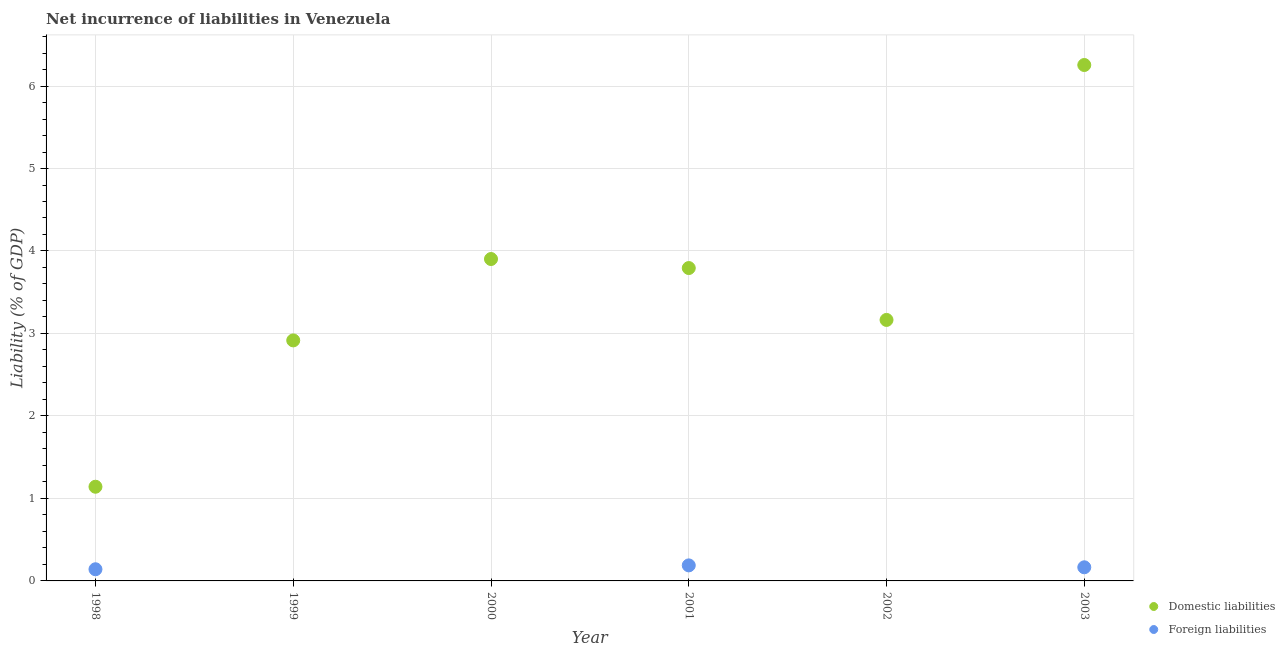Is the number of dotlines equal to the number of legend labels?
Offer a terse response. No. What is the incurrence of foreign liabilities in 1998?
Your answer should be compact. 0.14. Across all years, what is the maximum incurrence of foreign liabilities?
Provide a short and direct response. 0.19. Across all years, what is the minimum incurrence of domestic liabilities?
Provide a succinct answer. 1.14. In which year was the incurrence of domestic liabilities maximum?
Your answer should be very brief. 2003. What is the total incurrence of domestic liabilities in the graph?
Keep it short and to the point. 21.17. What is the difference between the incurrence of domestic liabilities in 2000 and that in 2003?
Your answer should be very brief. -2.35. What is the difference between the incurrence of domestic liabilities in 1998 and the incurrence of foreign liabilities in 2000?
Ensure brevity in your answer.  1.14. What is the average incurrence of foreign liabilities per year?
Give a very brief answer. 0.08. In the year 2001, what is the difference between the incurrence of foreign liabilities and incurrence of domestic liabilities?
Offer a terse response. -3.6. What is the ratio of the incurrence of domestic liabilities in 2000 to that in 2002?
Offer a very short reply. 1.23. Is the incurrence of domestic liabilities in 2001 less than that in 2002?
Ensure brevity in your answer.  No. What is the difference between the highest and the second highest incurrence of foreign liabilities?
Offer a very short reply. 0.02. What is the difference between the highest and the lowest incurrence of domestic liabilities?
Your answer should be compact. 5.11. Does the incurrence of domestic liabilities monotonically increase over the years?
Your answer should be compact. No. How many dotlines are there?
Your answer should be very brief. 2. How many years are there in the graph?
Give a very brief answer. 6. Does the graph contain any zero values?
Your response must be concise. Yes. Does the graph contain grids?
Provide a succinct answer. Yes. Where does the legend appear in the graph?
Provide a succinct answer. Bottom right. How many legend labels are there?
Your answer should be very brief. 2. How are the legend labels stacked?
Provide a short and direct response. Vertical. What is the title of the graph?
Provide a short and direct response. Net incurrence of liabilities in Venezuela. What is the label or title of the X-axis?
Provide a short and direct response. Year. What is the label or title of the Y-axis?
Offer a terse response. Liability (% of GDP). What is the Liability (% of GDP) of Domestic liabilities in 1998?
Your answer should be compact. 1.14. What is the Liability (% of GDP) in Foreign liabilities in 1998?
Ensure brevity in your answer.  0.14. What is the Liability (% of GDP) of Domestic liabilities in 1999?
Give a very brief answer. 2.92. What is the Liability (% of GDP) of Foreign liabilities in 1999?
Your response must be concise. 0. What is the Liability (% of GDP) in Domestic liabilities in 2000?
Make the answer very short. 3.9. What is the Liability (% of GDP) in Foreign liabilities in 2000?
Your answer should be compact. 0. What is the Liability (% of GDP) in Domestic liabilities in 2001?
Give a very brief answer. 3.79. What is the Liability (% of GDP) of Foreign liabilities in 2001?
Your answer should be compact. 0.19. What is the Liability (% of GDP) of Domestic liabilities in 2002?
Offer a very short reply. 3.16. What is the Liability (% of GDP) in Foreign liabilities in 2002?
Your answer should be compact. 0. What is the Liability (% of GDP) in Domestic liabilities in 2003?
Provide a succinct answer. 6.25. What is the Liability (% of GDP) in Foreign liabilities in 2003?
Your answer should be compact. 0.17. Across all years, what is the maximum Liability (% of GDP) in Domestic liabilities?
Ensure brevity in your answer.  6.25. Across all years, what is the maximum Liability (% of GDP) of Foreign liabilities?
Provide a succinct answer. 0.19. Across all years, what is the minimum Liability (% of GDP) of Domestic liabilities?
Keep it short and to the point. 1.14. Across all years, what is the minimum Liability (% of GDP) of Foreign liabilities?
Keep it short and to the point. 0. What is the total Liability (% of GDP) in Domestic liabilities in the graph?
Your response must be concise. 21.17. What is the total Liability (% of GDP) in Foreign liabilities in the graph?
Make the answer very short. 0.49. What is the difference between the Liability (% of GDP) in Domestic liabilities in 1998 and that in 1999?
Keep it short and to the point. -1.77. What is the difference between the Liability (% of GDP) in Domestic liabilities in 1998 and that in 2000?
Ensure brevity in your answer.  -2.76. What is the difference between the Liability (% of GDP) in Domestic liabilities in 1998 and that in 2001?
Your answer should be very brief. -2.65. What is the difference between the Liability (% of GDP) in Foreign liabilities in 1998 and that in 2001?
Your answer should be compact. -0.05. What is the difference between the Liability (% of GDP) of Domestic liabilities in 1998 and that in 2002?
Your answer should be compact. -2.02. What is the difference between the Liability (% of GDP) of Domestic liabilities in 1998 and that in 2003?
Your response must be concise. -5.11. What is the difference between the Liability (% of GDP) in Foreign liabilities in 1998 and that in 2003?
Give a very brief answer. -0.02. What is the difference between the Liability (% of GDP) in Domestic liabilities in 1999 and that in 2000?
Ensure brevity in your answer.  -0.99. What is the difference between the Liability (% of GDP) in Domestic liabilities in 1999 and that in 2001?
Ensure brevity in your answer.  -0.88. What is the difference between the Liability (% of GDP) in Domestic liabilities in 1999 and that in 2002?
Make the answer very short. -0.25. What is the difference between the Liability (% of GDP) of Domestic liabilities in 1999 and that in 2003?
Provide a succinct answer. -3.34. What is the difference between the Liability (% of GDP) in Domestic liabilities in 2000 and that in 2001?
Your answer should be very brief. 0.11. What is the difference between the Liability (% of GDP) of Domestic liabilities in 2000 and that in 2002?
Ensure brevity in your answer.  0.74. What is the difference between the Liability (% of GDP) in Domestic liabilities in 2000 and that in 2003?
Make the answer very short. -2.35. What is the difference between the Liability (% of GDP) in Domestic liabilities in 2001 and that in 2002?
Your answer should be compact. 0.63. What is the difference between the Liability (% of GDP) of Domestic liabilities in 2001 and that in 2003?
Your answer should be very brief. -2.46. What is the difference between the Liability (% of GDP) in Foreign liabilities in 2001 and that in 2003?
Your response must be concise. 0.02. What is the difference between the Liability (% of GDP) in Domestic liabilities in 2002 and that in 2003?
Offer a terse response. -3.09. What is the difference between the Liability (% of GDP) in Domestic liabilities in 1998 and the Liability (% of GDP) in Foreign liabilities in 2001?
Keep it short and to the point. 0.95. What is the difference between the Liability (% of GDP) of Domestic liabilities in 1998 and the Liability (% of GDP) of Foreign liabilities in 2003?
Your response must be concise. 0.98. What is the difference between the Liability (% of GDP) of Domestic liabilities in 1999 and the Liability (% of GDP) of Foreign liabilities in 2001?
Make the answer very short. 2.73. What is the difference between the Liability (% of GDP) of Domestic liabilities in 1999 and the Liability (% of GDP) of Foreign liabilities in 2003?
Provide a succinct answer. 2.75. What is the difference between the Liability (% of GDP) in Domestic liabilities in 2000 and the Liability (% of GDP) in Foreign liabilities in 2001?
Offer a very short reply. 3.71. What is the difference between the Liability (% of GDP) of Domestic liabilities in 2000 and the Liability (% of GDP) of Foreign liabilities in 2003?
Offer a terse response. 3.74. What is the difference between the Liability (% of GDP) of Domestic liabilities in 2001 and the Liability (% of GDP) of Foreign liabilities in 2003?
Provide a short and direct response. 3.63. What is the difference between the Liability (% of GDP) of Domestic liabilities in 2002 and the Liability (% of GDP) of Foreign liabilities in 2003?
Offer a very short reply. 3. What is the average Liability (% of GDP) in Domestic liabilities per year?
Make the answer very short. 3.53. What is the average Liability (% of GDP) of Foreign liabilities per year?
Your answer should be compact. 0.08. In the year 1998, what is the difference between the Liability (% of GDP) in Domestic liabilities and Liability (% of GDP) in Foreign liabilities?
Make the answer very short. 1. In the year 2001, what is the difference between the Liability (% of GDP) of Domestic liabilities and Liability (% of GDP) of Foreign liabilities?
Your response must be concise. 3.6. In the year 2003, what is the difference between the Liability (% of GDP) in Domestic liabilities and Liability (% of GDP) in Foreign liabilities?
Your answer should be very brief. 6.09. What is the ratio of the Liability (% of GDP) in Domestic liabilities in 1998 to that in 1999?
Provide a short and direct response. 0.39. What is the ratio of the Liability (% of GDP) of Domestic liabilities in 1998 to that in 2000?
Your response must be concise. 0.29. What is the ratio of the Liability (% of GDP) in Domestic liabilities in 1998 to that in 2001?
Ensure brevity in your answer.  0.3. What is the ratio of the Liability (% of GDP) in Foreign liabilities in 1998 to that in 2001?
Your answer should be very brief. 0.75. What is the ratio of the Liability (% of GDP) of Domestic liabilities in 1998 to that in 2002?
Keep it short and to the point. 0.36. What is the ratio of the Liability (% of GDP) of Domestic liabilities in 1998 to that in 2003?
Your answer should be compact. 0.18. What is the ratio of the Liability (% of GDP) in Foreign liabilities in 1998 to that in 2003?
Offer a very short reply. 0.86. What is the ratio of the Liability (% of GDP) of Domestic liabilities in 1999 to that in 2000?
Offer a very short reply. 0.75. What is the ratio of the Liability (% of GDP) of Domestic liabilities in 1999 to that in 2001?
Offer a terse response. 0.77. What is the ratio of the Liability (% of GDP) in Domestic liabilities in 1999 to that in 2002?
Give a very brief answer. 0.92. What is the ratio of the Liability (% of GDP) of Domestic liabilities in 1999 to that in 2003?
Your answer should be very brief. 0.47. What is the ratio of the Liability (% of GDP) in Domestic liabilities in 2000 to that in 2001?
Your response must be concise. 1.03. What is the ratio of the Liability (% of GDP) of Domestic liabilities in 2000 to that in 2002?
Offer a terse response. 1.23. What is the ratio of the Liability (% of GDP) in Domestic liabilities in 2000 to that in 2003?
Ensure brevity in your answer.  0.62. What is the ratio of the Liability (% of GDP) of Domestic liabilities in 2001 to that in 2002?
Keep it short and to the point. 1.2. What is the ratio of the Liability (% of GDP) in Domestic liabilities in 2001 to that in 2003?
Provide a succinct answer. 0.61. What is the ratio of the Liability (% of GDP) of Foreign liabilities in 2001 to that in 2003?
Your answer should be very brief. 1.14. What is the ratio of the Liability (% of GDP) of Domestic liabilities in 2002 to that in 2003?
Give a very brief answer. 0.51. What is the difference between the highest and the second highest Liability (% of GDP) of Domestic liabilities?
Your answer should be very brief. 2.35. What is the difference between the highest and the second highest Liability (% of GDP) in Foreign liabilities?
Make the answer very short. 0.02. What is the difference between the highest and the lowest Liability (% of GDP) of Domestic liabilities?
Ensure brevity in your answer.  5.11. What is the difference between the highest and the lowest Liability (% of GDP) in Foreign liabilities?
Your answer should be compact. 0.19. 